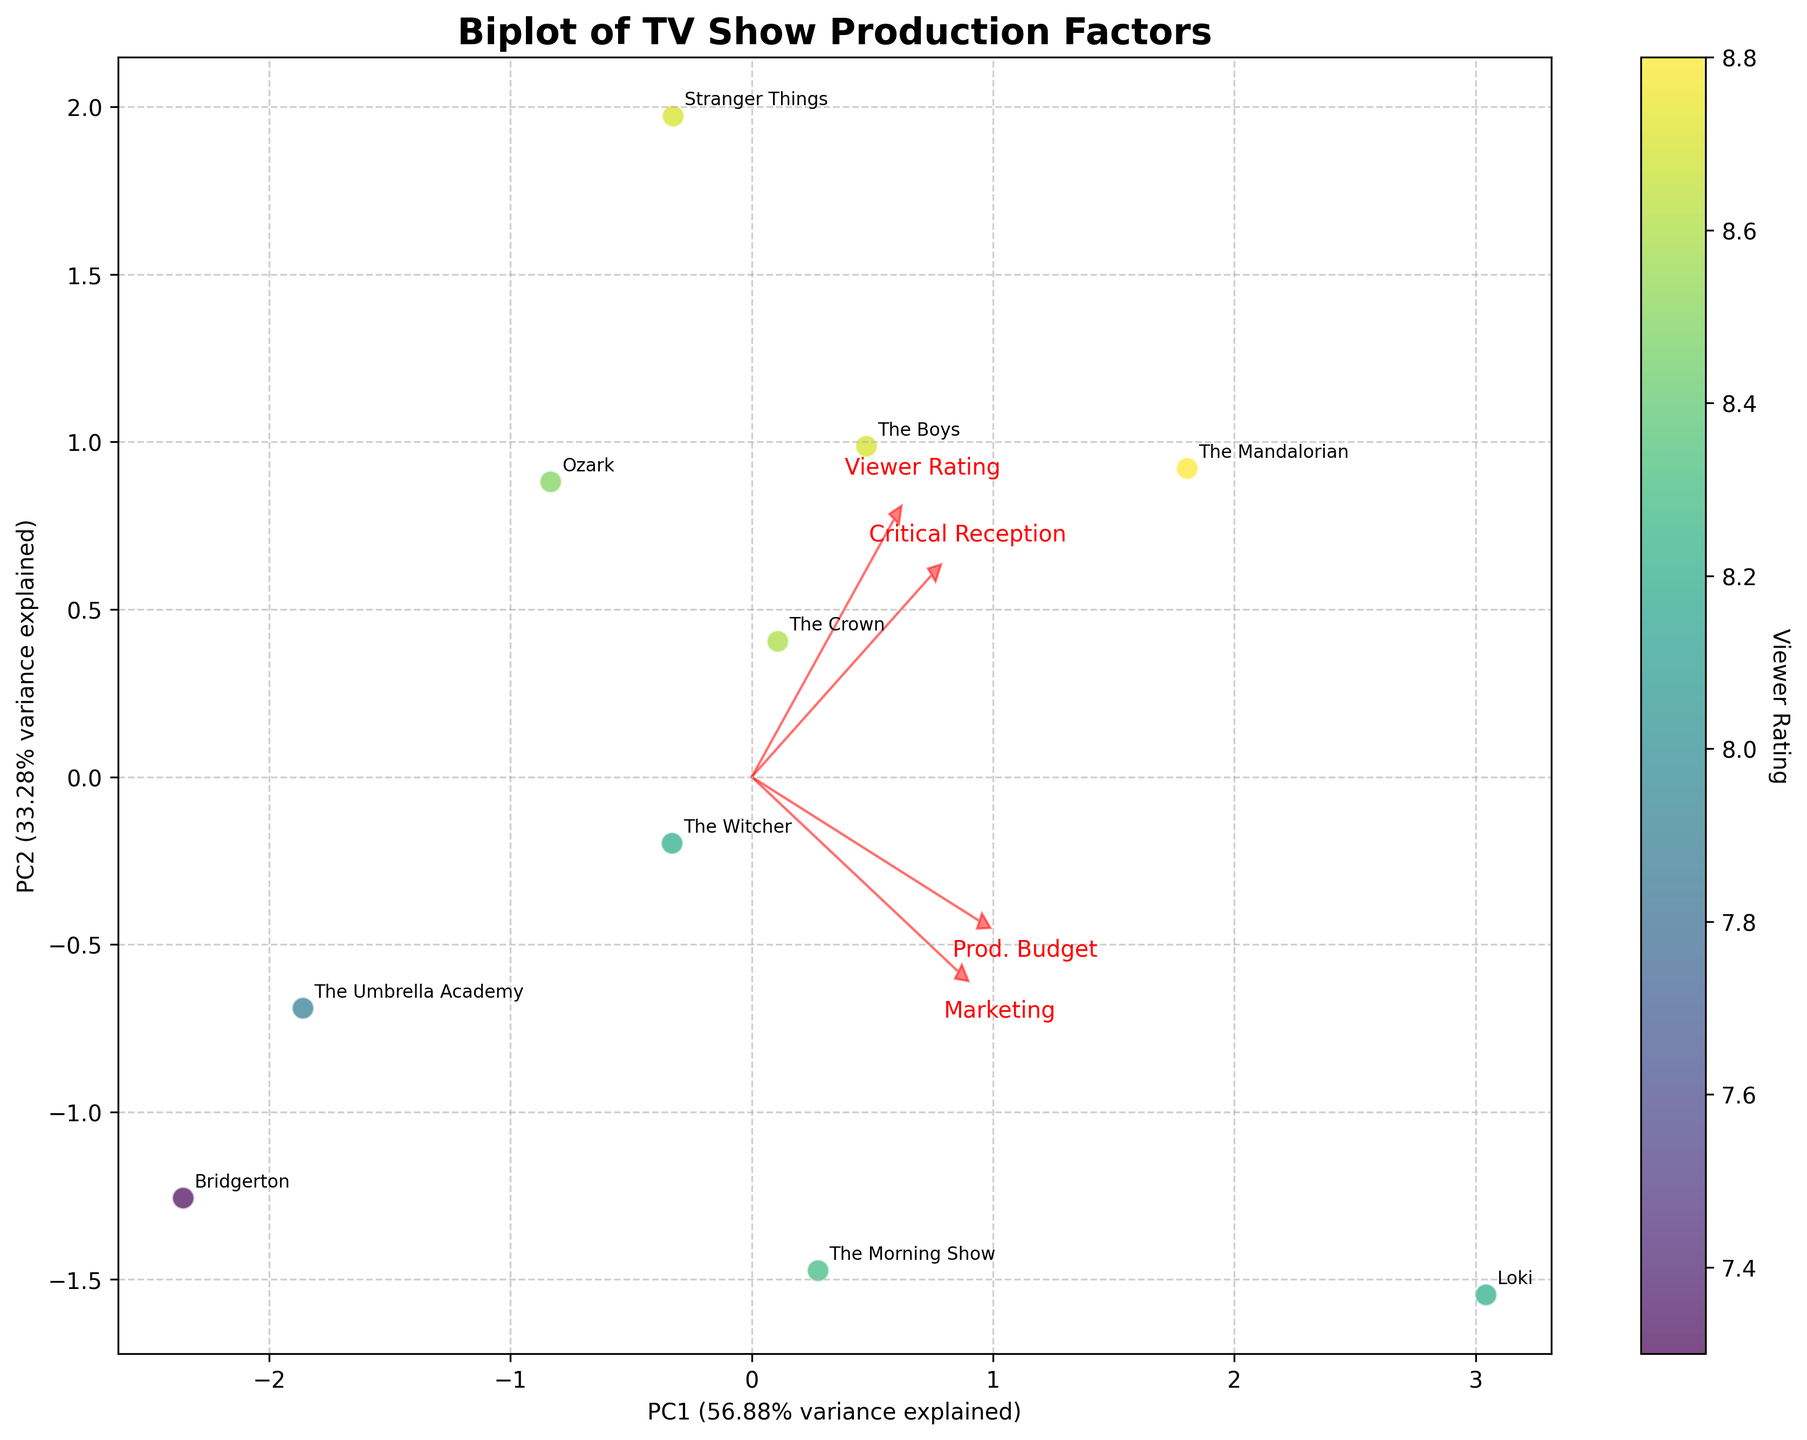Which show has the highest viewer rating? Look at the color indicator and the viewer rating scale. The Mandalorian has the highest viewer rating colored by the upper value bracket.
Answer: The Mandalorian What are the axis labels and their explained variances? The x-axis is labeled 'PC1 (x% variance explained)' and the y-axis is labeled 'PC2 (y% variance explained)' where x and y are percentages of the total variance explained by the principal components.
Answer: PC1 (~43.87% variance explained), PC2 (~33.83% variance explained) Which arrow represents the 'Production Budget'? There are four arrows labeled 'Prod. Budget', 'Marketing', 'Viewer Rating', and 'Critical Reception'. Identify the one labeled 'Prod. Budget'.
Answer: The arrow labeled 'Prod. Budget' Which show uses the highest production budget? Check for the data points and annotations closest to the tip of the 'Prod. Budget' arrow. Loki is closest to this end.
Answer: Loki What is the relationship between 'Marketing Budget' and 'Viewer Rating'? Observe the directions of the arrows. If they point in a similar direction or nearly parallel, they are positively correlated.
Answer: Positive correlation Which shows are most similar based on their positions in the plot? Look for data points and annotations that are closely located. For example, Stranger Things and The Boys are close to each other.
Answer: Stranger Things and The Boys Does 'Critical Reception' appear to affect the 'Viewer Rating'? Check if the 'Critical Reception' arrow points similarly to the 'Viewer Rating' arrow or if shows with high ratings are near the 'Critical Reception' arrow.
Answer: Yes, it is likely positively correlated Which show has the combination of high production and marketing budgets? Find the data points close to the tips of both 'Prod. Budget' and 'Marketing' arrows. Loki is near both these tips.
Answer: Loki How much of the total variance is explained by the first two principal components? Sum the percentages from the x-axis (PC1) and the y-axis (PC2) labels. 43.87 + 33.83 = 77.7.
Answer: ~77.7% Which factor loading appears to have the least influence on the plot? Compare the lengths of all arrows representing the factors. The shortest arrow indicates the least influence.
Answer: Viewer Rating 